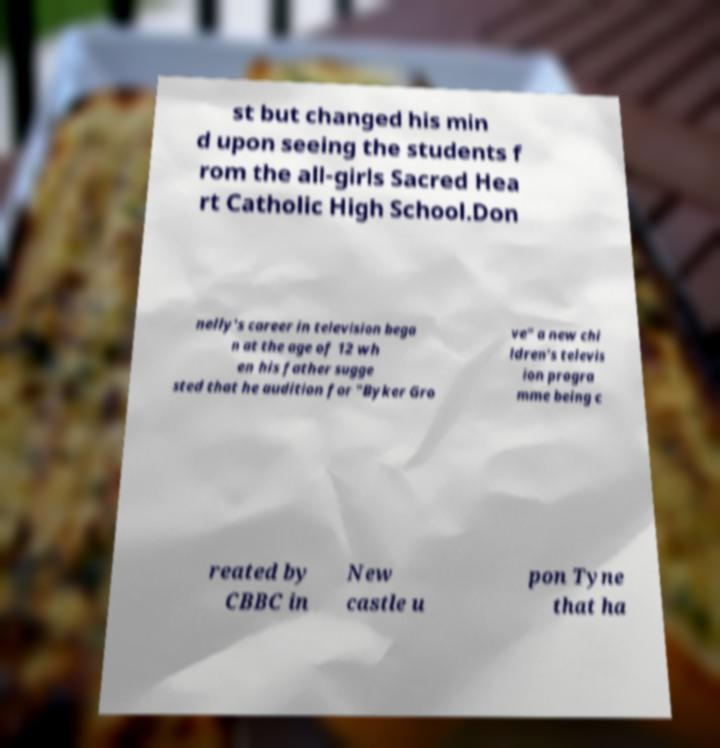I need the written content from this picture converted into text. Can you do that? st but changed his min d upon seeing the students f rom the all-girls Sacred Hea rt Catholic High School.Don nelly's career in television bega n at the age of 12 wh en his father sugge sted that he audition for "Byker Gro ve" a new chi ldren's televis ion progra mme being c reated by CBBC in New castle u pon Tyne that ha 